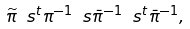<formula> <loc_0><loc_0><loc_500><loc_500>\widetilde { \pi } \ s { ^ { t } } { \pi } ^ { - 1 } \ s \bar { \pi } ^ { - 1 } \ s { ^ { t } } \bar { \pi } ^ { - 1 } ,</formula> 